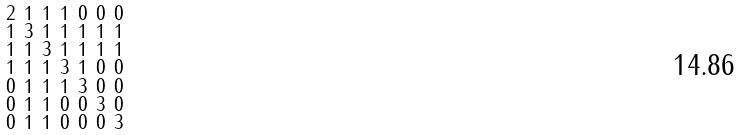Convert formula to latex. <formula><loc_0><loc_0><loc_500><loc_500>\begin{smallmatrix} 2 & 1 & 1 & 1 & 0 & 0 & 0 \\ 1 & 3 & 1 & 1 & 1 & 1 & 1 \\ 1 & 1 & 3 & 1 & 1 & 1 & 1 \\ 1 & 1 & 1 & 3 & 1 & 0 & 0 \\ 0 & 1 & 1 & 1 & 3 & 0 & 0 \\ 0 & 1 & 1 & 0 & 0 & 3 & 0 \\ 0 & 1 & 1 & 0 & 0 & 0 & 3 \end{smallmatrix}</formula> 